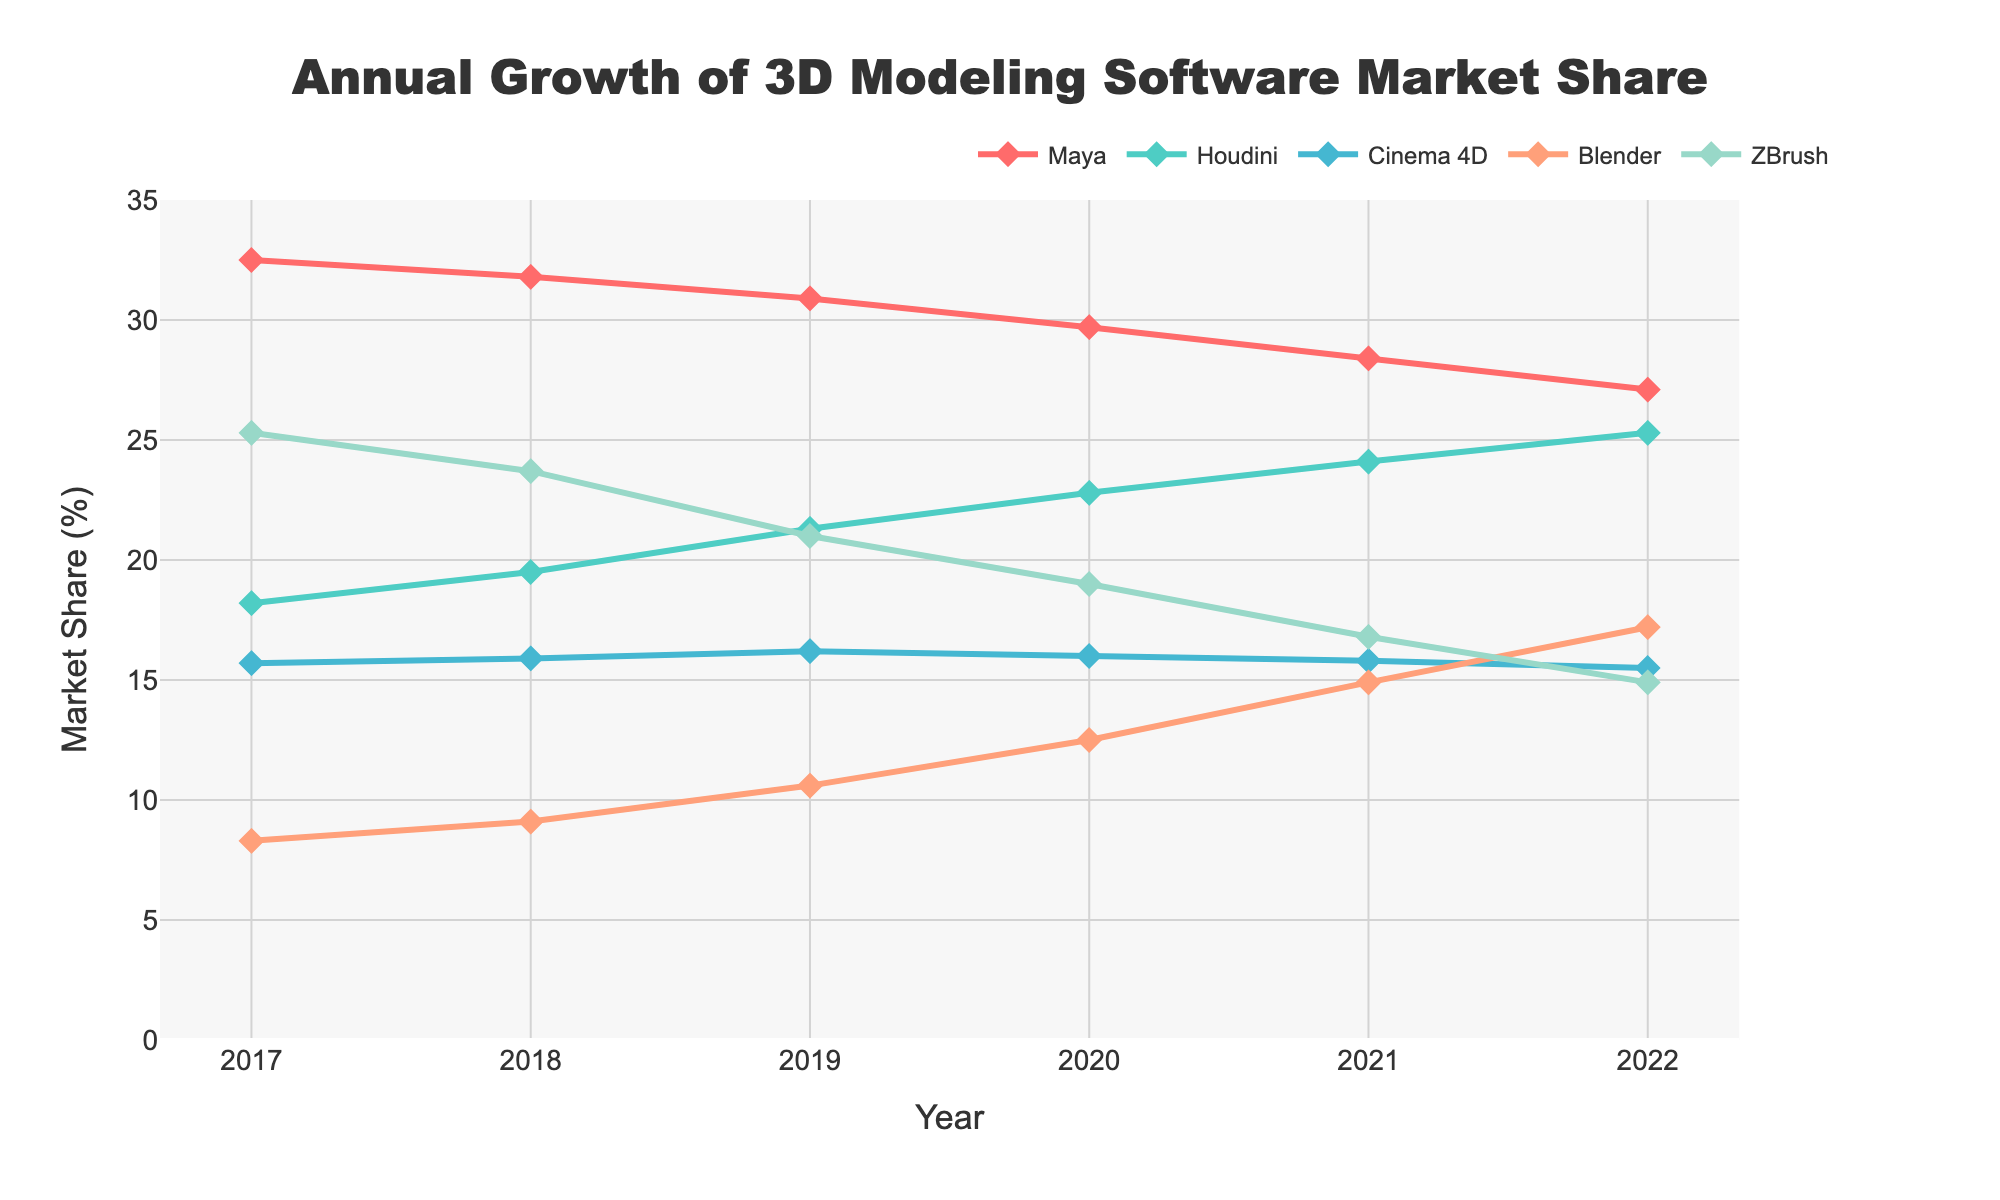How has Maya's market share changed from 2017 to 2022? The value of Maya's market share in 2017 is 32.5%. In 2022, it is 27.1%. The change in Maya's market share is 27.1% - 32.5% = -5.4%, indicating a decline.
Answer: Declined by 5.4% Which software had the highest market share in 2022? In 2022, the data values for market shares are: Maya (27.1%), Houdini (25.3%), Cinema 4D (15.5%), Blender (17.2%), ZBrush (14.9%). Houdini has the highest market share among these.
Answer: Houdini Between which consecutive years did Houdini see the largest increase in market share? Houdini's market share changes from 2017 (18.2%) to 2018 (19.5%) by 1.3%, from 2018 (19.5%) to 2019 (21.3%) by 1.8%, from 2019 (21.3%) to 2020 (22.8%) by 1.5%, from 2020 (22.8%) to 2021 (24.1%) by 1.3%, and from 2021 (24.1%) to 2022 (25.3%) by 1.2%. The largest increase is from 2018 to 2019 by 1.8%.
Answer: 2018 to 2019 Is Blender's growth rate increasing or stabilizing between 2021 and 2022? From 2020 to 2021, Blender's market share increased by 14.9% - 12.5% = 2.4%. From 2021 to 2022, it increased by 17.2% - 14.9% = 2.3%. The growth rate is slightly decreasing by 0.1%.
Answer: Slightly decreasing Which software shows a consistent decline in market share over the years? Reviewing the trends from 2017 to 2022 for each software: Maya consistently declines from 32.5% to 27.1%. Houdini consistently increases. Cinema 4D shows slight fluctuations. Blender consistently increases. ZBrush consistently declines from 25.3% to 14.9%. Thus, Maya and ZBrush show consistent declines.
Answer: Maya and ZBrush What was the combined market share of Blender and Cinema 4D in 2020? Blender's market share in 2020 is 12.5%. Cinema 4D's market share in 2020 is 16.0%. The combined market share is 12.5% + 16.0% = 28.5%.
Answer: 28.5% By how much did ZBrush's market share decrease from 2017 to 2022? ZBrush's market share in 2017 is 25.3%. In 2022, it is 14.9%. The decrease is 25.3% - 14.9% = 10.4%.
Answer: 10.4% Among all the software, which one had the most stable market share and how can you tell? Comparing the changes for each software across the years: Maya and ZBrush show declines; Houdini and Blender show increases; Cinema 4D's figures are relatively stable with slight variations around 15-16%. Thus, Cinema 4D is the most stable.
Answer: Cinema 4D 